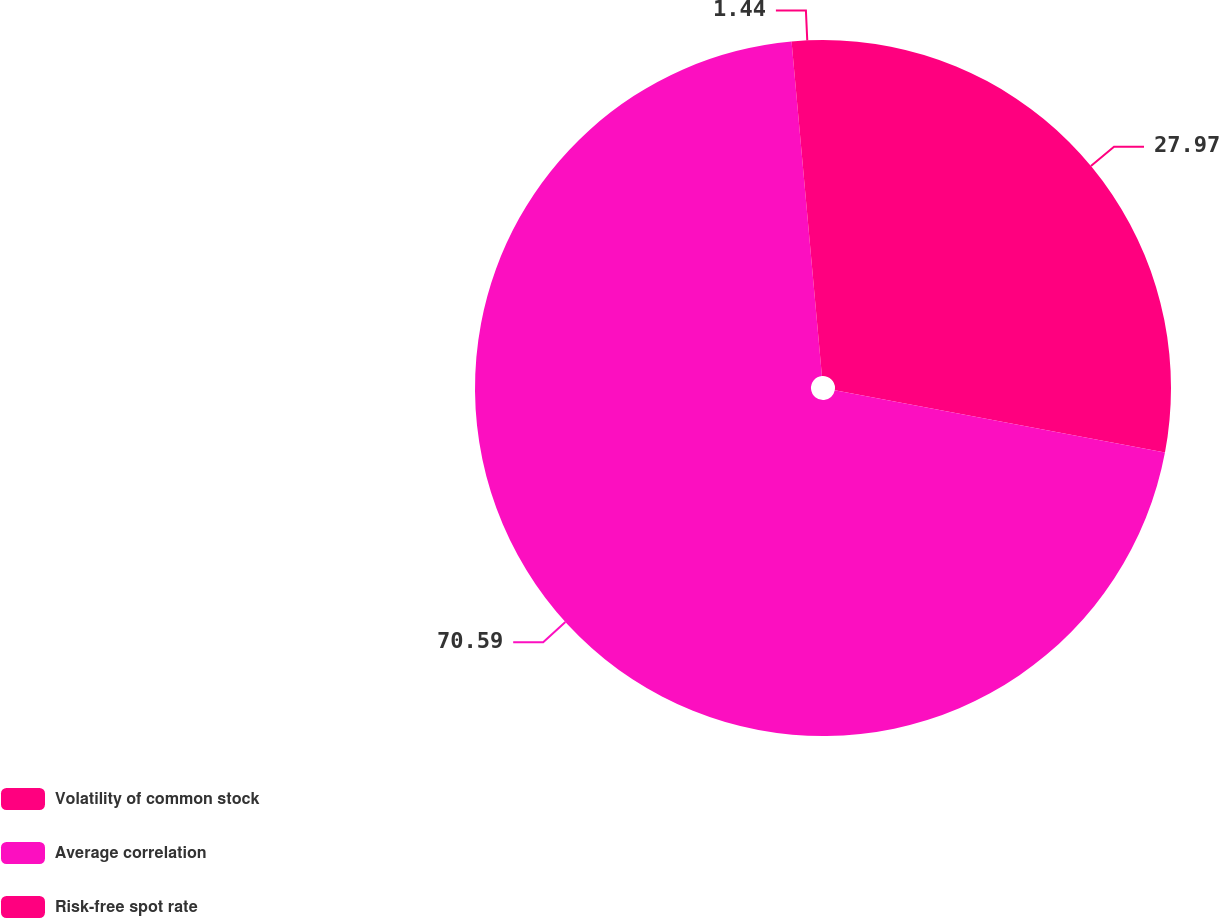Convert chart to OTSL. <chart><loc_0><loc_0><loc_500><loc_500><pie_chart><fcel>Volatility of common stock<fcel>Average correlation<fcel>Risk-free spot rate<nl><fcel>27.97%<fcel>70.59%<fcel>1.44%<nl></chart> 